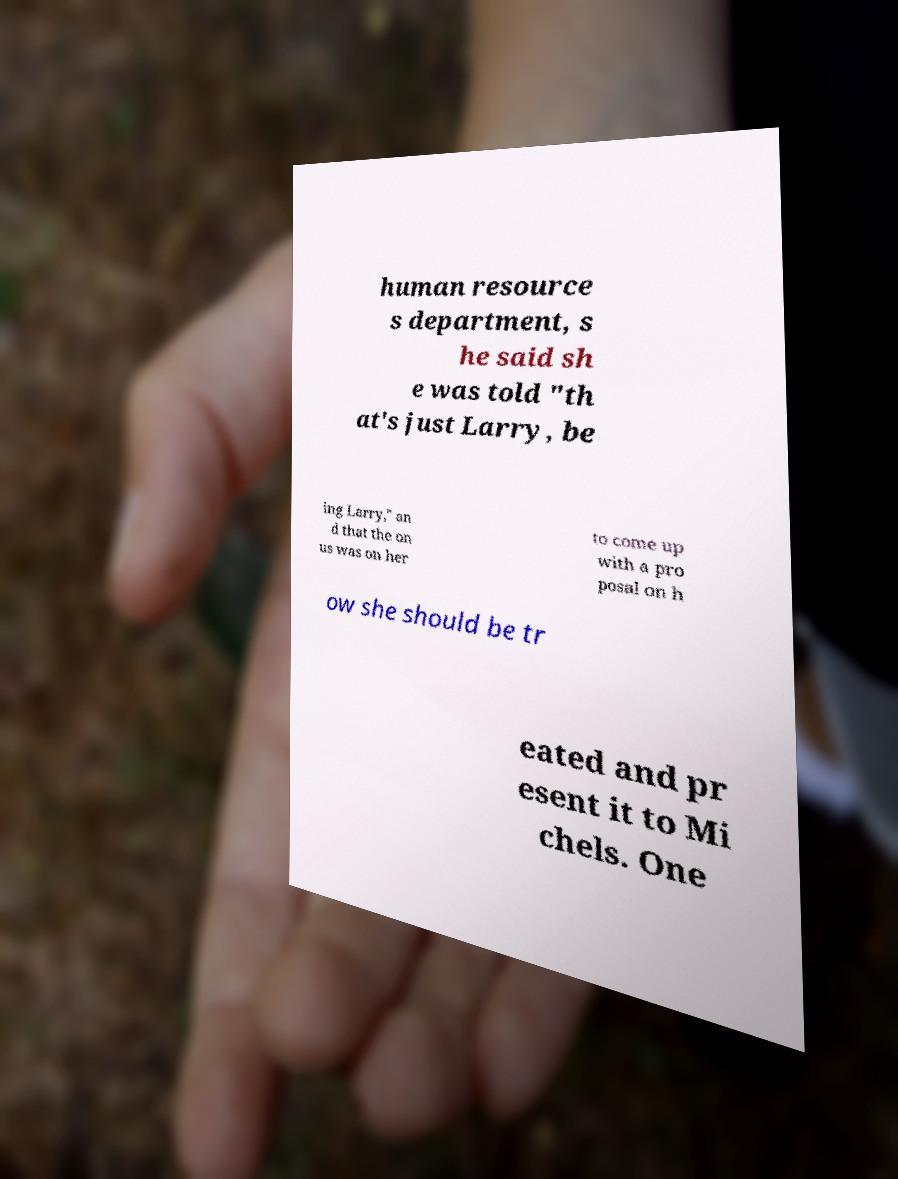Can you accurately transcribe the text from the provided image for me? human resource s department, s he said sh e was told "th at's just Larry, be ing Larry," an d that the on us was on her to come up with a pro posal on h ow she should be tr eated and pr esent it to Mi chels. One 